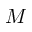Convert formula to latex. <formula><loc_0><loc_0><loc_500><loc_500>M</formula> 